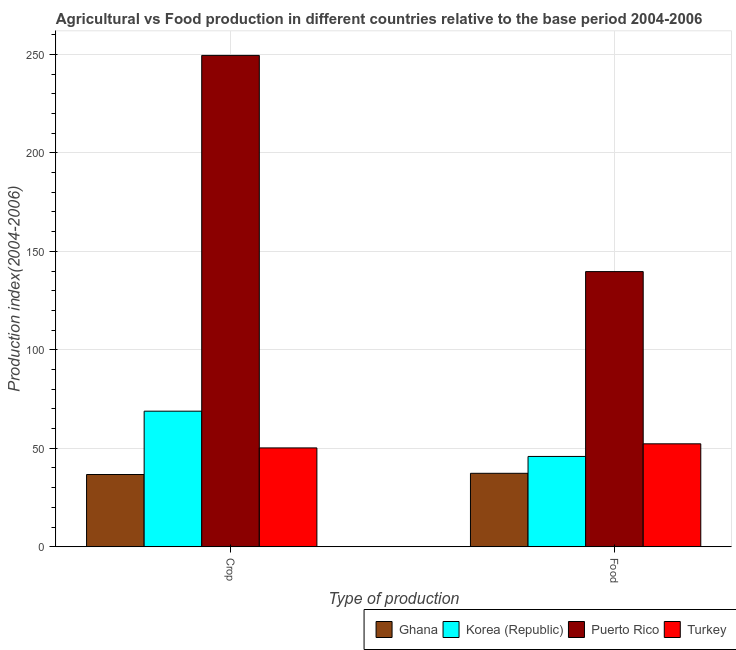How many groups of bars are there?
Provide a short and direct response. 2. What is the label of the 2nd group of bars from the left?
Give a very brief answer. Food. What is the crop production index in Turkey?
Offer a very short reply. 50.19. Across all countries, what is the maximum food production index?
Your response must be concise. 139.73. Across all countries, what is the minimum crop production index?
Your response must be concise. 36.69. In which country was the crop production index maximum?
Provide a succinct answer. Puerto Rico. In which country was the food production index minimum?
Give a very brief answer. Ghana. What is the total food production index in the graph?
Your answer should be very brief. 275.16. What is the difference between the food production index in Puerto Rico and that in Korea (Republic)?
Give a very brief answer. 93.87. What is the difference between the food production index in Puerto Rico and the crop production index in Korea (Republic)?
Provide a succinct answer. 70.88. What is the average food production index per country?
Keep it short and to the point. 68.79. What is the difference between the food production index and crop production index in Ghana?
Keep it short and to the point. 0.61. In how many countries, is the food production index greater than 150 ?
Offer a very short reply. 0. What is the ratio of the crop production index in Korea (Republic) to that in Puerto Rico?
Your answer should be very brief. 0.28. What does the 1st bar from the left in Food represents?
Your response must be concise. Ghana. What does the 3rd bar from the right in Crop represents?
Ensure brevity in your answer.  Korea (Republic). Are all the bars in the graph horizontal?
Offer a terse response. No. How many countries are there in the graph?
Offer a terse response. 4. What is the difference between two consecutive major ticks on the Y-axis?
Provide a succinct answer. 50. Does the graph contain any zero values?
Your answer should be very brief. No. Does the graph contain grids?
Keep it short and to the point. Yes. Where does the legend appear in the graph?
Ensure brevity in your answer.  Bottom right. What is the title of the graph?
Offer a terse response. Agricultural vs Food production in different countries relative to the base period 2004-2006. What is the label or title of the X-axis?
Give a very brief answer. Type of production. What is the label or title of the Y-axis?
Give a very brief answer. Production index(2004-2006). What is the Production index(2004-2006) in Ghana in Crop?
Offer a very short reply. 36.69. What is the Production index(2004-2006) in Korea (Republic) in Crop?
Give a very brief answer. 68.85. What is the Production index(2004-2006) in Puerto Rico in Crop?
Your answer should be compact. 249.52. What is the Production index(2004-2006) in Turkey in Crop?
Your answer should be compact. 50.19. What is the Production index(2004-2006) in Ghana in Food?
Give a very brief answer. 37.3. What is the Production index(2004-2006) in Korea (Republic) in Food?
Your response must be concise. 45.86. What is the Production index(2004-2006) in Puerto Rico in Food?
Provide a short and direct response. 139.73. What is the Production index(2004-2006) in Turkey in Food?
Ensure brevity in your answer.  52.27. Across all Type of production, what is the maximum Production index(2004-2006) in Ghana?
Offer a very short reply. 37.3. Across all Type of production, what is the maximum Production index(2004-2006) of Korea (Republic)?
Make the answer very short. 68.85. Across all Type of production, what is the maximum Production index(2004-2006) of Puerto Rico?
Provide a short and direct response. 249.52. Across all Type of production, what is the maximum Production index(2004-2006) of Turkey?
Your answer should be compact. 52.27. Across all Type of production, what is the minimum Production index(2004-2006) in Ghana?
Offer a very short reply. 36.69. Across all Type of production, what is the minimum Production index(2004-2006) in Korea (Republic)?
Provide a succinct answer. 45.86. Across all Type of production, what is the minimum Production index(2004-2006) of Puerto Rico?
Offer a terse response. 139.73. Across all Type of production, what is the minimum Production index(2004-2006) in Turkey?
Ensure brevity in your answer.  50.19. What is the total Production index(2004-2006) in Ghana in the graph?
Your answer should be very brief. 73.99. What is the total Production index(2004-2006) of Korea (Republic) in the graph?
Keep it short and to the point. 114.71. What is the total Production index(2004-2006) in Puerto Rico in the graph?
Make the answer very short. 389.25. What is the total Production index(2004-2006) in Turkey in the graph?
Offer a terse response. 102.46. What is the difference between the Production index(2004-2006) of Ghana in Crop and that in Food?
Provide a succinct answer. -0.61. What is the difference between the Production index(2004-2006) of Korea (Republic) in Crop and that in Food?
Your answer should be compact. 22.99. What is the difference between the Production index(2004-2006) in Puerto Rico in Crop and that in Food?
Ensure brevity in your answer.  109.79. What is the difference between the Production index(2004-2006) of Turkey in Crop and that in Food?
Your answer should be compact. -2.08. What is the difference between the Production index(2004-2006) in Ghana in Crop and the Production index(2004-2006) in Korea (Republic) in Food?
Your response must be concise. -9.17. What is the difference between the Production index(2004-2006) in Ghana in Crop and the Production index(2004-2006) in Puerto Rico in Food?
Your answer should be very brief. -103.04. What is the difference between the Production index(2004-2006) of Ghana in Crop and the Production index(2004-2006) of Turkey in Food?
Ensure brevity in your answer.  -15.58. What is the difference between the Production index(2004-2006) of Korea (Republic) in Crop and the Production index(2004-2006) of Puerto Rico in Food?
Offer a very short reply. -70.88. What is the difference between the Production index(2004-2006) in Korea (Republic) in Crop and the Production index(2004-2006) in Turkey in Food?
Make the answer very short. 16.58. What is the difference between the Production index(2004-2006) in Puerto Rico in Crop and the Production index(2004-2006) in Turkey in Food?
Provide a short and direct response. 197.25. What is the average Production index(2004-2006) in Ghana per Type of production?
Provide a succinct answer. 36.99. What is the average Production index(2004-2006) of Korea (Republic) per Type of production?
Give a very brief answer. 57.35. What is the average Production index(2004-2006) of Puerto Rico per Type of production?
Provide a succinct answer. 194.62. What is the average Production index(2004-2006) of Turkey per Type of production?
Give a very brief answer. 51.23. What is the difference between the Production index(2004-2006) in Ghana and Production index(2004-2006) in Korea (Republic) in Crop?
Your answer should be compact. -32.16. What is the difference between the Production index(2004-2006) of Ghana and Production index(2004-2006) of Puerto Rico in Crop?
Offer a terse response. -212.83. What is the difference between the Production index(2004-2006) in Korea (Republic) and Production index(2004-2006) in Puerto Rico in Crop?
Ensure brevity in your answer.  -180.67. What is the difference between the Production index(2004-2006) of Korea (Republic) and Production index(2004-2006) of Turkey in Crop?
Provide a succinct answer. 18.66. What is the difference between the Production index(2004-2006) of Puerto Rico and Production index(2004-2006) of Turkey in Crop?
Give a very brief answer. 199.33. What is the difference between the Production index(2004-2006) of Ghana and Production index(2004-2006) of Korea (Republic) in Food?
Offer a terse response. -8.56. What is the difference between the Production index(2004-2006) in Ghana and Production index(2004-2006) in Puerto Rico in Food?
Provide a short and direct response. -102.43. What is the difference between the Production index(2004-2006) in Ghana and Production index(2004-2006) in Turkey in Food?
Provide a succinct answer. -14.97. What is the difference between the Production index(2004-2006) in Korea (Republic) and Production index(2004-2006) in Puerto Rico in Food?
Your response must be concise. -93.87. What is the difference between the Production index(2004-2006) in Korea (Republic) and Production index(2004-2006) in Turkey in Food?
Your answer should be compact. -6.41. What is the difference between the Production index(2004-2006) in Puerto Rico and Production index(2004-2006) in Turkey in Food?
Make the answer very short. 87.46. What is the ratio of the Production index(2004-2006) of Ghana in Crop to that in Food?
Provide a succinct answer. 0.98. What is the ratio of the Production index(2004-2006) of Korea (Republic) in Crop to that in Food?
Offer a very short reply. 1.5. What is the ratio of the Production index(2004-2006) in Puerto Rico in Crop to that in Food?
Offer a very short reply. 1.79. What is the ratio of the Production index(2004-2006) in Turkey in Crop to that in Food?
Provide a short and direct response. 0.96. What is the difference between the highest and the second highest Production index(2004-2006) of Ghana?
Offer a very short reply. 0.61. What is the difference between the highest and the second highest Production index(2004-2006) of Korea (Republic)?
Your answer should be very brief. 22.99. What is the difference between the highest and the second highest Production index(2004-2006) of Puerto Rico?
Your response must be concise. 109.79. What is the difference between the highest and the second highest Production index(2004-2006) in Turkey?
Provide a short and direct response. 2.08. What is the difference between the highest and the lowest Production index(2004-2006) in Ghana?
Your response must be concise. 0.61. What is the difference between the highest and the lowest Production index(2004-2006) in Korea (Republic)?
Offer a very short reply. 22.99. What is the difference between the highest and the lowest Production index(2004-2006) of Puerto Rico?
Provide a short and direct response. 109.79. What is the difference between the highest and the lowest Production index(2004-2006) of Turkey?
Provide a short and direct response. 2.08. 